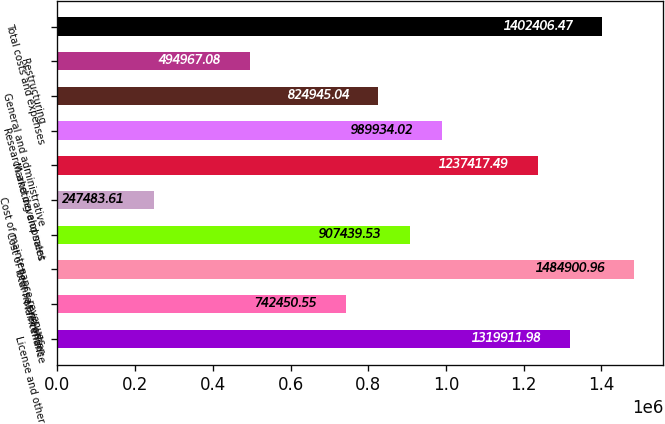Convert chart. <chart><loc_0><loc_0><loc_500><loc_500><bar_chart><fcel>License and other<fcel>Maintenance<fcel>Total net revenues<fcel>Cost of license and other<fcel>Cost of maintenance revenues<fcel>Marketing and sales<fcel>Research and development<fcel>General and administrative<fcel>Restructuring<fcel>Total costs and expenses<nl><fcel>1.31991e+06<fcel>742451<fcel>1.4849e+06<fcel>907440<fcel>247484<fcel>1.23742e+06<fcel>989934<fcel>824945<fcel>494967<fcel>1.40241e+06<nl></chart> 